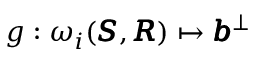<formula> <loc_0><loc_0><loc_500><loc_500>g \colon \omega _ { i } ( \pm b { S } , \pm b { R } ) \mapsto \pm b { b } ^ { \bot }</formula> 